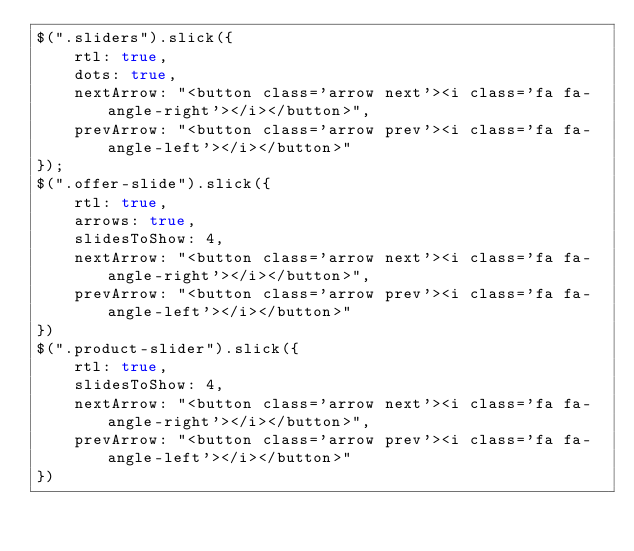<code> <loc_0><loc_0><loc_500><loc_500><_JavaScript_>$(".sliders").slick({
    rtl: true,
    dots: true,
    nextArrow: "<button class='arrow next'><i class='fa fa-angle-right'></i></button>",
    prevArrow: "<button class='arrow prev'><i class='fa fa-angle-left'></i></button>"
});
$(".offer-slide").slick({
    rtl: true,
    arrows: true,
    slidesToShow: 4,
    nextArrow: "<button class='arrow next'><i class='fa fa-angle-right'></i></button>",
    prevArrow: "<button class='arrow prev'><i class='fa fa-angle-left'></i></button>"
})
$(".product-slider").slick({
    rtl: true,
    slidesToShow: 4,
    nextArrow: "<button class='arrow next'><i class='fa fa-angle-right'></i></button>",
    prevArrow: "<button class='arrow prev'><i class='fa fa-angle-left'></i></button>"
})</code> 